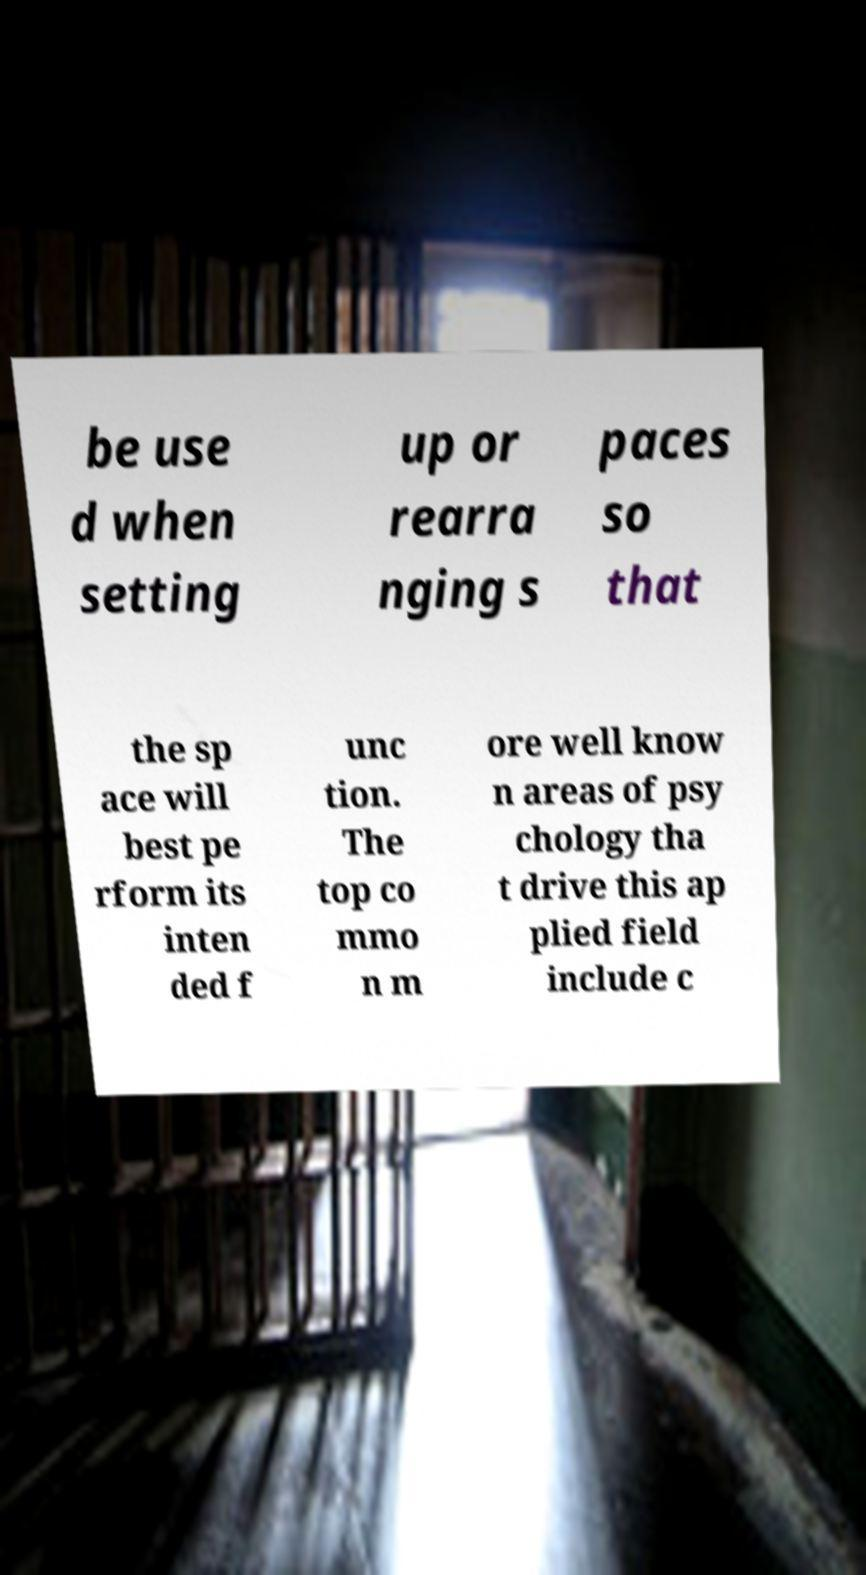For documentation purposes, I need the text within this image transcribed. Could you provide that? be use d when setting up or rearra nging s paces so that the sp ace will best pe rform its inten ded f unc tion. The top co mmo n m ore well know n areas of psy chology tha t drive this ap plied field include c 